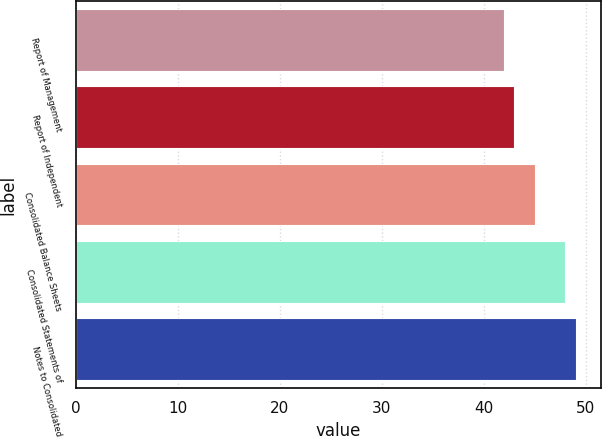Convert chart. <chart><loc_0><loc_0><loc_500><loc_500><bar_chart><fcel>Report of Management<fcel>Report of Independent<fcel>Consolidated Balance Sheets<fcel>Consolidated Statements of<fcel>Notes to Consolidated<nl><fcel>42<fcel>43<fcel>45<fcel>48<fcel>49<nl></chart> 